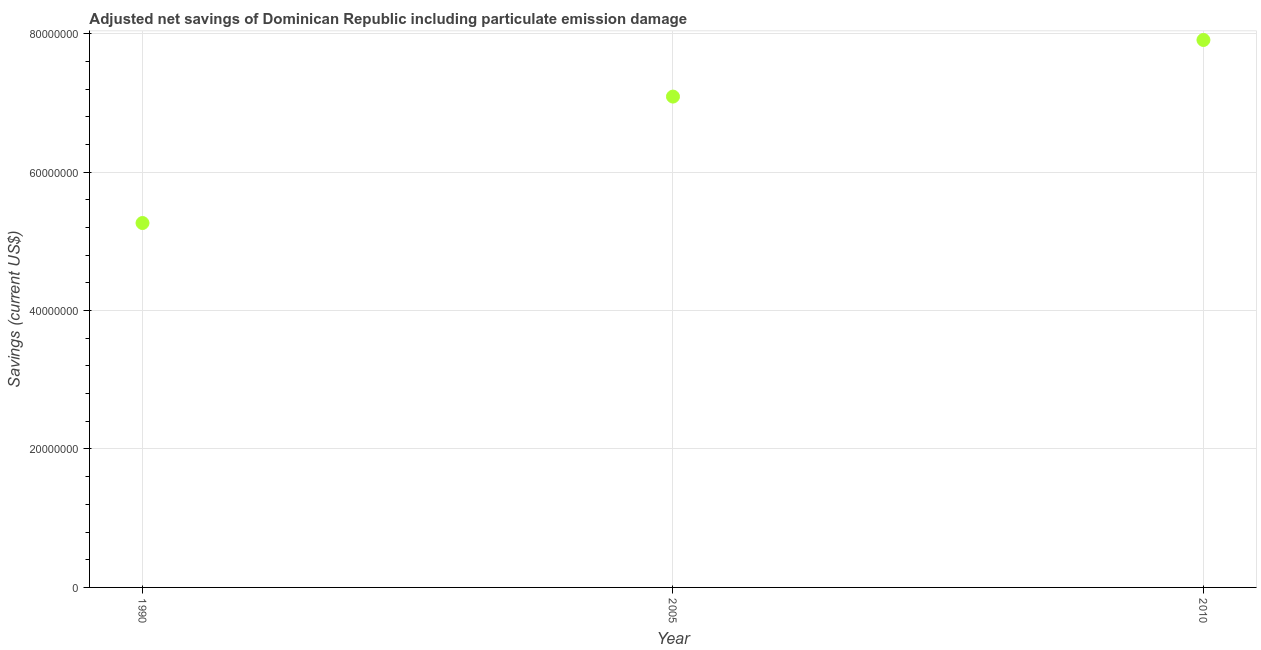What is the adjusted net savings in 1990?
Offer a terse response. 5.26e+07. Across all years, what is the maximum adjusted net savings?
Offer a very short reply. 7.91e+07. Across all years, what is the minimum adjusted net savings?
Your answer should be compact. 5.26e+07. What is the sum of the adjusted net savings?
Your answer should be compact. 2.03e+08. What is the difference between the adjusted net savings in 1990 and 2005?
Offer a very short reply. -1.83e+07. What is the average adjusted net savings per year?
Offer a terse response. 6.75e+07. What is the median adjusted net savings?
Keep it short and to the point. 7.09e+07. What is the ratio of the adjusted net savings in 2005 to that in 2010?
Ensure brevity in your answer.  0.9. What is the difference between the highest and the second highest adjusted net savings?
Ensure brevity in your answer.  8.18e+06. What is the difference between the highest and the lowest adjusted net savings?
Your response must be concise. 2.64e+07. In how many years, is the adjusted net savings greater than the average adjusted net savings taken over all years?
Provide a short and direct response. 2. Does the adjusted net savings monotonically increase over the years?
Your answer should be compact. Yes. What is the difference between two consecutive major ticks on the Y-axis?
Provide a short and direct response. 2.00e+07. Does the graph contain any zero values?
Provide a short and direct response. No. What is the title of the graph?
Your response must be concise. Adjusted net savings of Dominican Republic including particulate emission damage. What is the label or title of the X-axis?
Make the answer very short. Year. What is the label or title of the Y-axis?
Your answer should be very brief. Savings (current US$). What is the Savings (current US$) in 1990?
Offer a very short reply. 5.26e+07. What is the Savings (current US$) in 2005?
Your response must be concise. 7.09e+07. What is the Savings (current US$) in 2010?
Your answer should be very brief. 7.91e+07. What is the difference between the Savings (current US$) in 1990 and 2005?
Ensure brevity in your answer.  -1.83e+07. What is the difference between the Savings (current US$) in 1990 and 2010?
Your answer should be very brief. -2.64e+07. What is the difference between the Savings (current US$) in 2005 and 2010?
Provide a succinct answer. -8.18e+06. What is the ratio of the Savings (current US$) in 1990 to that in 2005?
Your answer should be very brief. 0.74. What is the ratio of the Savings (current US$) in 1990 to that in 2010?
Provide a succinct answer. 0.67. What is the ratio of the Savings (current US$) in 2005 to that in 2010?
Provide a short and direct response. 0.9. 